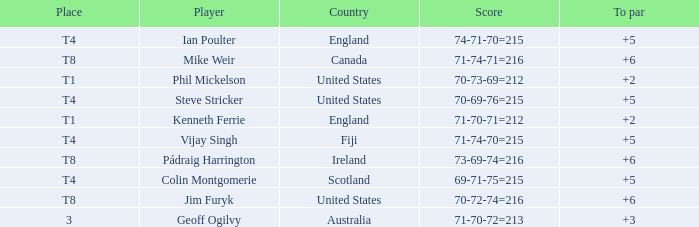What score to par did Mike Weir have? 6.0. 